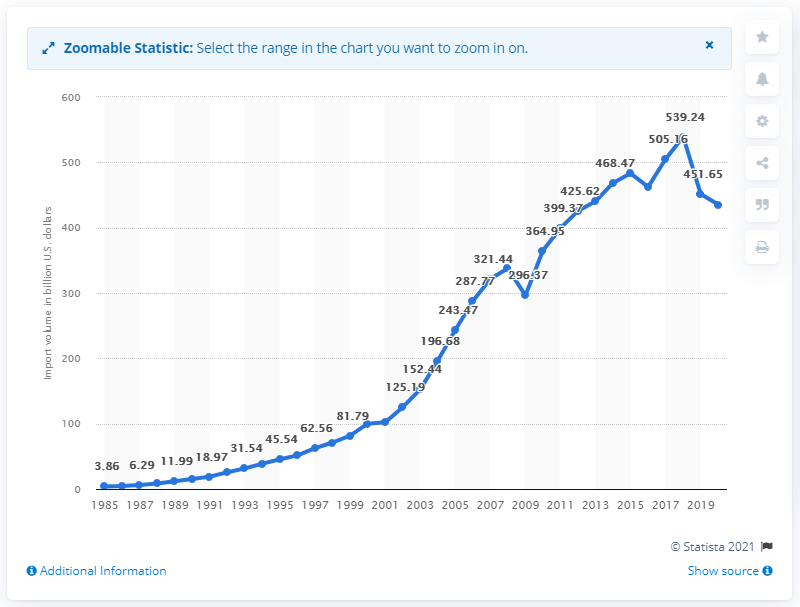Specify some key components in this picture. In 2020, the value of China's trade goods to the United States was approximately 435.45 billion dollars. In 1985, the value of imports from China to the United States was 3.86... 